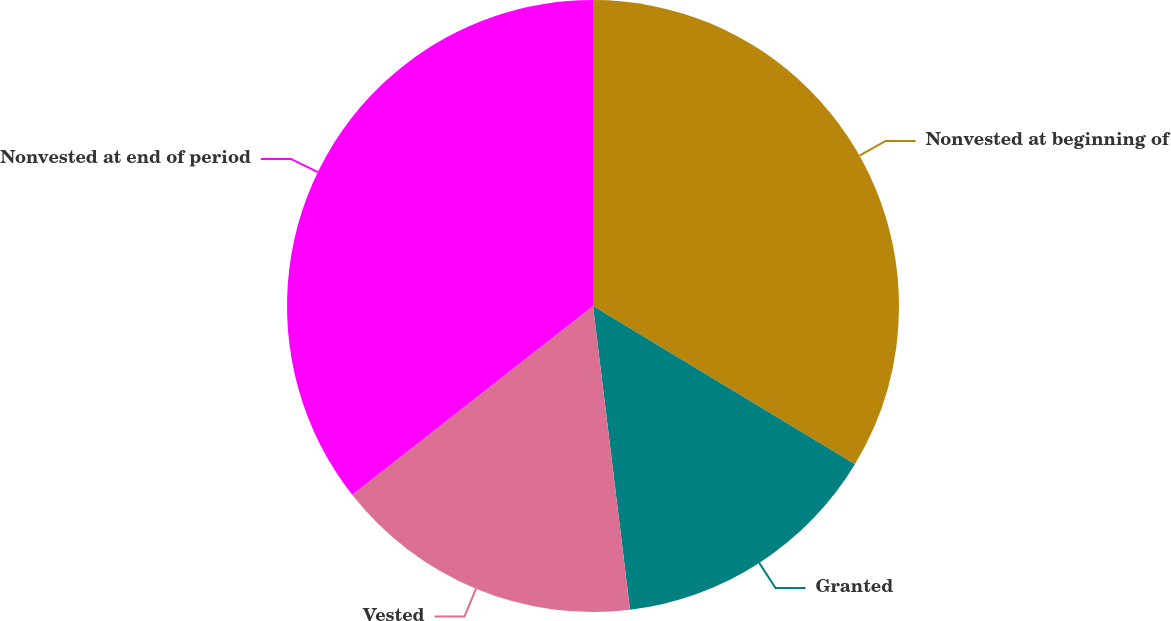Convert chart to OTSL. <chart><loc_0><loc_0><loc_500><loc_500><pie_chart><fcel>Nonvested at beginning of<fcel>Granted<fcel>Vested<fcel>Nonvested at end of period<nl><fcel>33.65%<fcel>14.42%<fcel>16.35%<fcel>35.58%<nl></chart> 